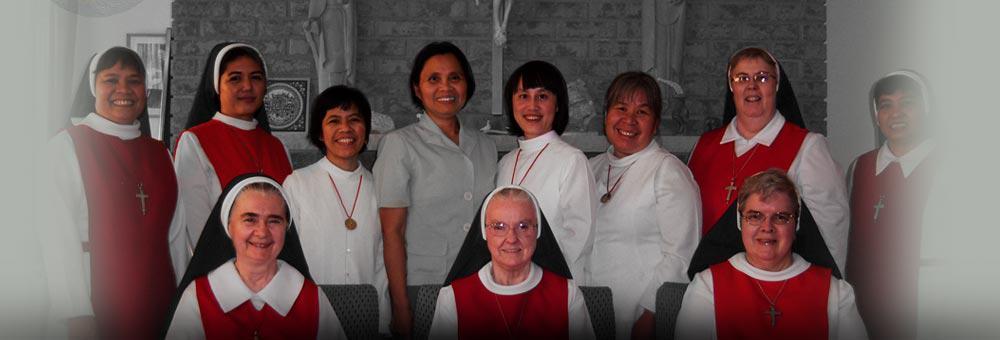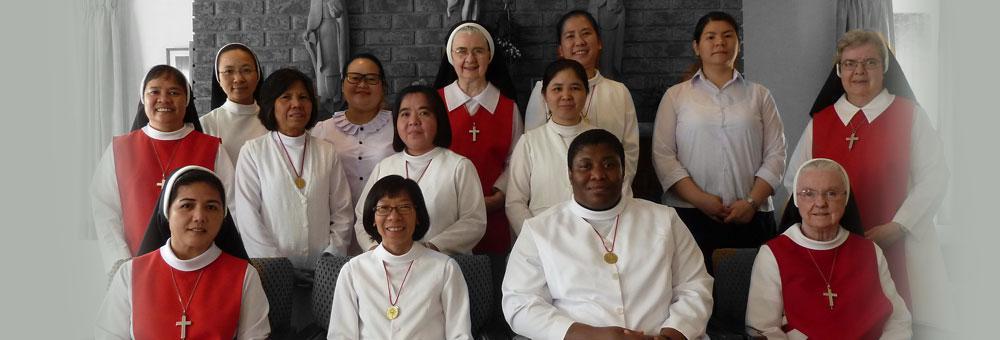The first image is the image on the left, the second image is the image on the right. Considering the images on both sides, is "Each image includes a woman wearing red and white and a woman wearing a black-and-white head covering, and the left image contains two people, while the right image contains three people." valid? Answer yes or no. No. The first image is the image on the left, the second image is the image on the right. Assess this claim about the two images: "There are women and no men.". Correct or not? Answer yes or no. Yes. 